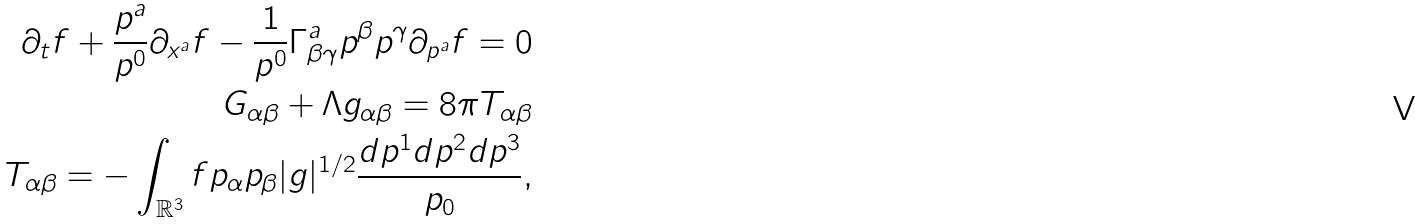<formula> <loc_0><loc_0><loc_500><loc_500>\partial _ { t } f + \frac { p ^ { a } } { p ^ { 0 } } \partial _ { x ^ { a } } f - \frac { 1 } { p ^ { 0 } } \Gamma _ { \beta \gamma } ^ { a } p ^ { \beta } p ^ { \gamma } \partial _ { p ^ { a } } f = 0 \\ G _ { \alpha \beta } + \Lambda g _ { \alpha \beta } = 8 \pi T _ { \alpha \beta } \\ T _ { \alpha \beta } = - \int _ { \mathbb { R } ^ { 3 } } f p _ { \alpha } p _ { \beta } | g | ^ { 1 / 2 } \frac { d p ^ { 1 } d p ^ { 2 } d p ^ { 3 } } { p _ { 0 } } ,</formula> 